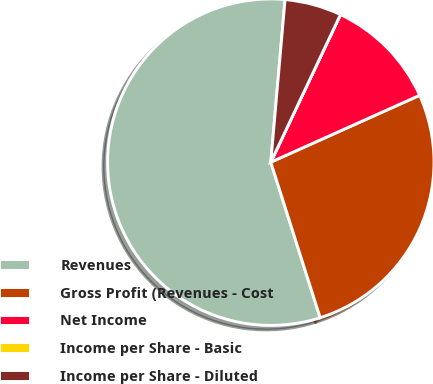Convert chart to OTSL. <chart><loc_0><loc_0><loc_500><loc_500><pie_chart><fcel>Revenues<fcel>Gross Profit (Revenues - Cost<fcel>Net Income<fcel>Income per Share - Basic<fcel>Income per Share - Diluted<nl><fcel>56.29%<fcel>26.83%<fcel>11.26%<fcel>0.0%<fcel>5.63%<nl></chart> 